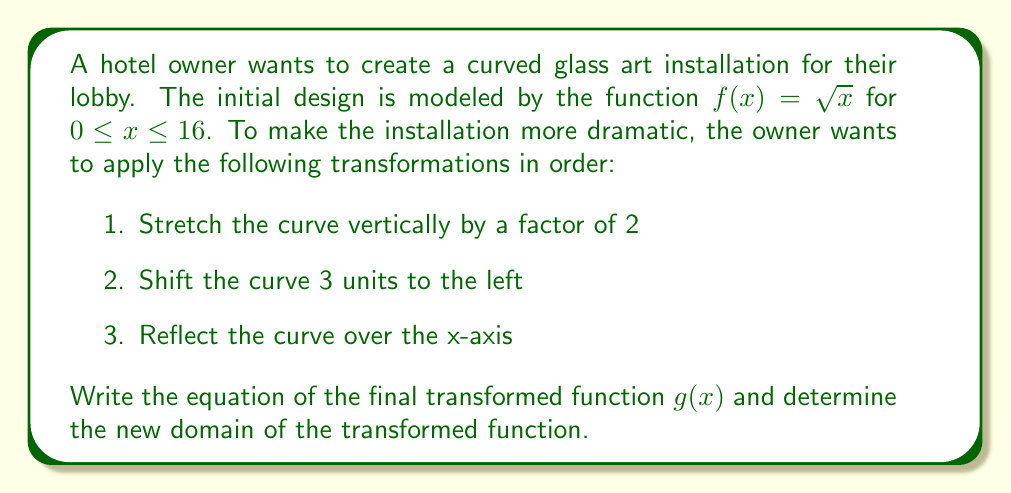Can you answer this question? Let's apply the transformations step by step:

1. Stretch vertically by a factor of 2:
   $f_1(x) = 2\sqrt{x}$

2. Shift 3 units to the left:
   $f_2(x) = 2\sqrt{x+3}$

3. Reflect over the x-axis:
   $g(x) = -2\sqrt{x+3}$

Now, let's determine the new domain:

The original domain was $0 \leq x \leq 16$.
After shifting 3 units to the left, we need to adjust the domain:
$0-3 \leq x-3 \leq 16-3$
$-3 \leq x-3 \leq 13$
$0 \leq x \leq 16$

Therefore, the new domain is $-3 \leq x \leq 13$.

To verify this, we can consider the expression under the square root:
$x + 3 \geq 0$
$x \geq -3$

This confirms that the left endpoint of the domain is indeed -3.

[asy]
import graph;
size(200,200);
real f(real x) {return -2*sqrt(x+3);}
draw(graph(f,-3,13));
xaxis("x");
yaxis("y");
label("$g(x)$", (5,-4));
[/asy]
Answer: The equation of the final transformed function is $g(x) = -2\sqrt{x+3}$ with domain $-3 \leq x \leq 13$. 